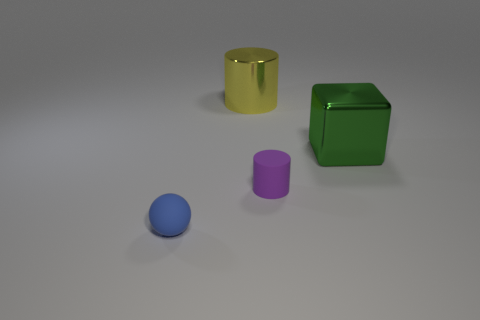Is there anything else that has the same size as the rubber sphere?
Your answer should be very brief. Yes. Is there any other thing that has the same color as the small cylinder?
Offer a very short reply. No. Are there more blue balls to the right of the small rubber cylinder than tiny purple shiny spheres?
Your answer should be very brief. No. What is the purple object made of?
Your answer should be very brief. Rubber. How many other gray matte spheres have the same size as the matte sphere?
Provide a short and direct response. 0. Are there the same number of cylinders to the left of the large yellow object and big blocks on the right side of the green shiny block?
Offer a terse response. Yes. Are the yellow cylinder and the blue object made of the same material?
Provide a succinct answer. No. There is a tiny thing to the right of the blue sphere; are there any large green shiny objects that are on the left side of it?
Make the answer very short. No. Are there any other small matte things of the same shape as the small purple object?
Offer a terse response. No. Does the ball have the same color as the metal cylinder?
Offer a terse response. No. 